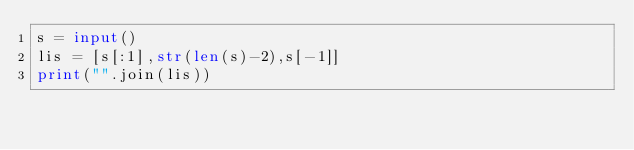<code> <loc_0><loc_0><loc_500><loc_500><_Python_>s = input()
lis = [s[:1],str(len(s)-2),s[-1]]
print("".join(lis))
</code> 